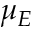Convert formula to latex. <formula><loc_0><loc_0><loc_500><loc_500>\mu _ { E }</formula> 